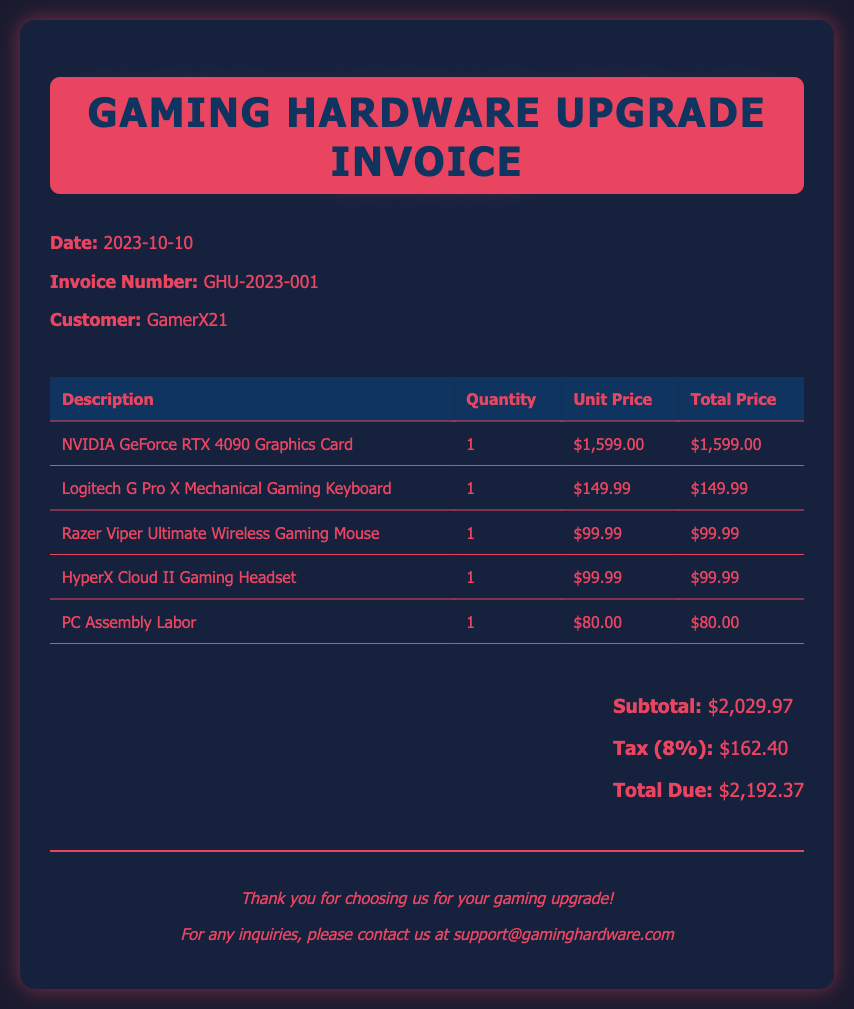What is the invoice number? The invoice number is specifically listed in the document under the invoice header section.
Answer: GHU-2023-001 What is the date of the invoice? The date is presented at the top of the invoice, providing a clear reference for the billing date.
Answer: 2023-10-10 What is the total due amount? The total due amount is calculated and clearly displayed in the summary section of the document.
Answer: $2,192.37 How much does the NVIDIA GeForce RTX 4090 Graphics Card cost? The price of the graphics card is itemized in the table with its respective unit price.
Answer: $1,599.00 What is the subtotal before tax? The subtotal is the sum of all item prices before tax, which can be found in the summary section.
Answer: $2,029.97 What is the tax percentage applied? The tax percentage is explicitly mentioned in the summary section under tax calculation.
Answer: 8% What is the price of the HyperX Cloud II Gaming Headset? The headset's price is listed within the itemized section of the invoice.
Answer: $99.99 How many peripherals are listed in the invoice? The number of peripherals can be counted from the itemized sections, including keyboard, mouse, and headset.
Answer: 3 What type of service is included in the assembly labor charge? The assembly labor charge refers to the service of constructing or assembling the PC, as stated in its description.
Answer: PC Assembly Labor 